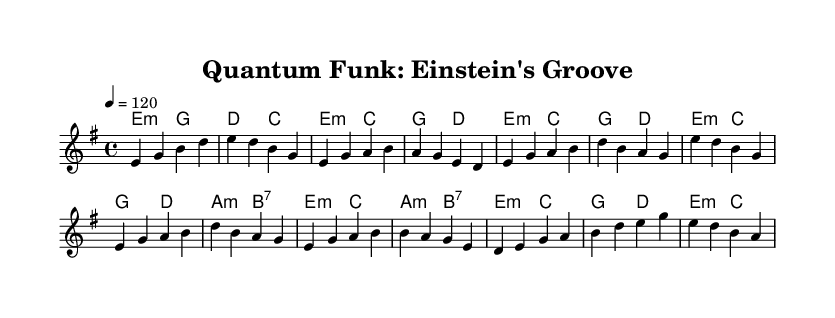What is the key signature of this music? The key signature is E minor, which has one sharp (F#). The key is indicated at the beginning of the score by the key signature markings.
Answer: E minor What is the time signature of this piece? The time signature is 4/4, which is shown at the beginning of the music. This tells us there are four beats in each measure, with a quarter note receiving one beat.
Answer: 4/4 What is the tempo marking indicated in the music? The tempo marking is "4 = 120," meaning that a quarter note should be played at a speed of 120 beats per minute. This is a common way to indicate tempo in sheet music.
Answer: 120 How many measures are in the Verse section? Counting the measures in the Verse section, we find that there are eight measures indicated. Each line typically corresponds to a different section, and the Verse is identified in the structure.
Answer: 8 What is the chord used in the Chorus section? The chords in the Chorus section include E minor, C major, G major, and A minor. These chords provide the harmonic framework for the melody in that section.
Answer: E minor, C major, G major, A minor What theme does the piece celebrate? The title of the piece "Quantum Funk: Einstein's Groove" suggests that it celebrates Albert Einstein and his contributions to physics, particularly in relation to quantum mechanics.
Answer: Albert Einstein Which musical element distinguishes Funk as a genre? The rhythmic groove and syncopation commonly found in Funk music are distinguishing elements. The combination of these rhythmic elements combined with a strong bass line often drives the feel of Funk tracks.
Answer: Rhythm and syncopation 